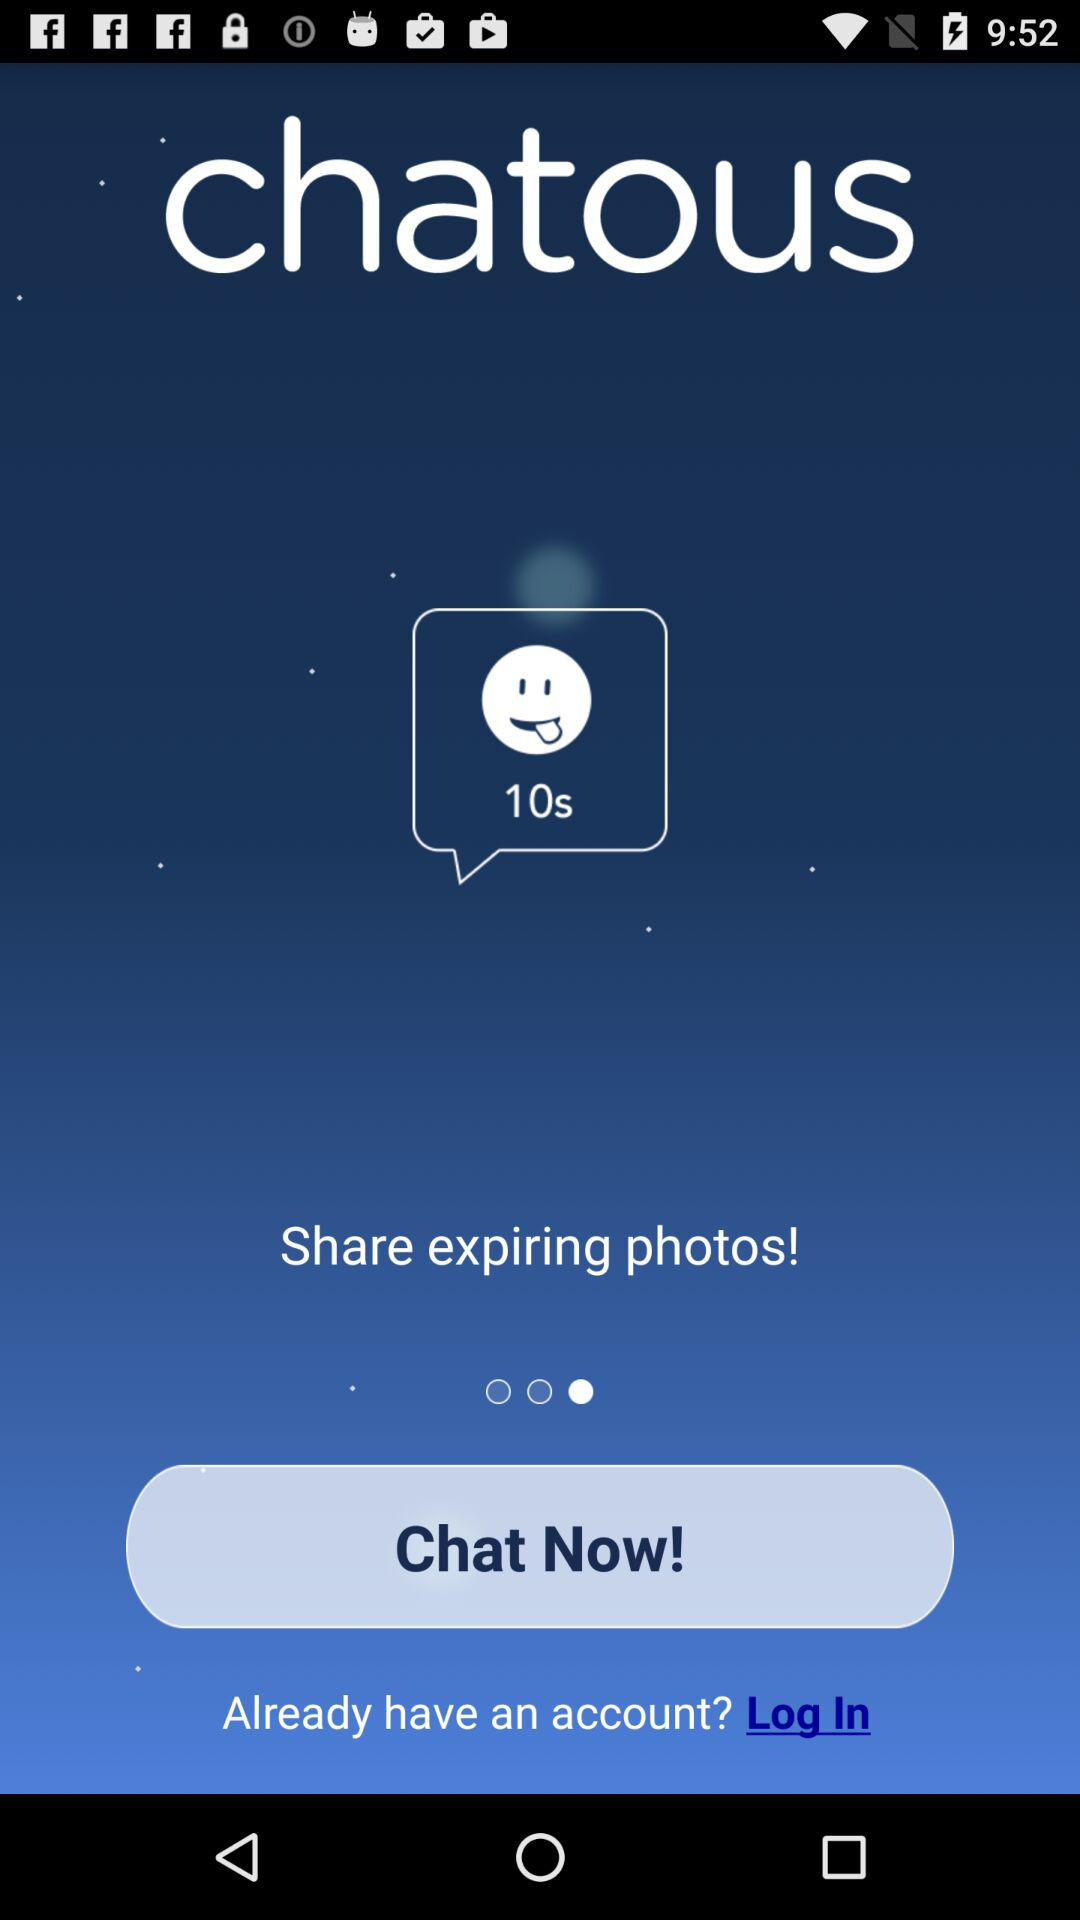What is the application name? The application name is "chatous". 